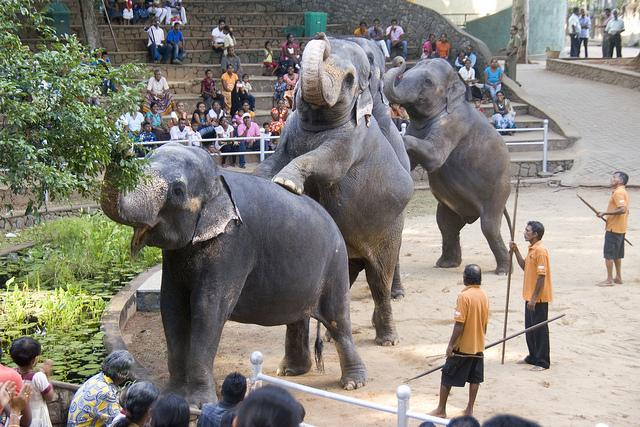What animals might be found in the pond here?

Choices:
A) cats
B) dogs
C) fish
D) elephants fish 